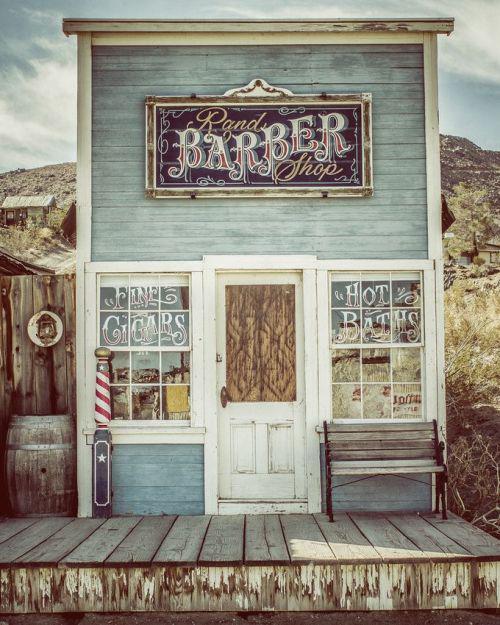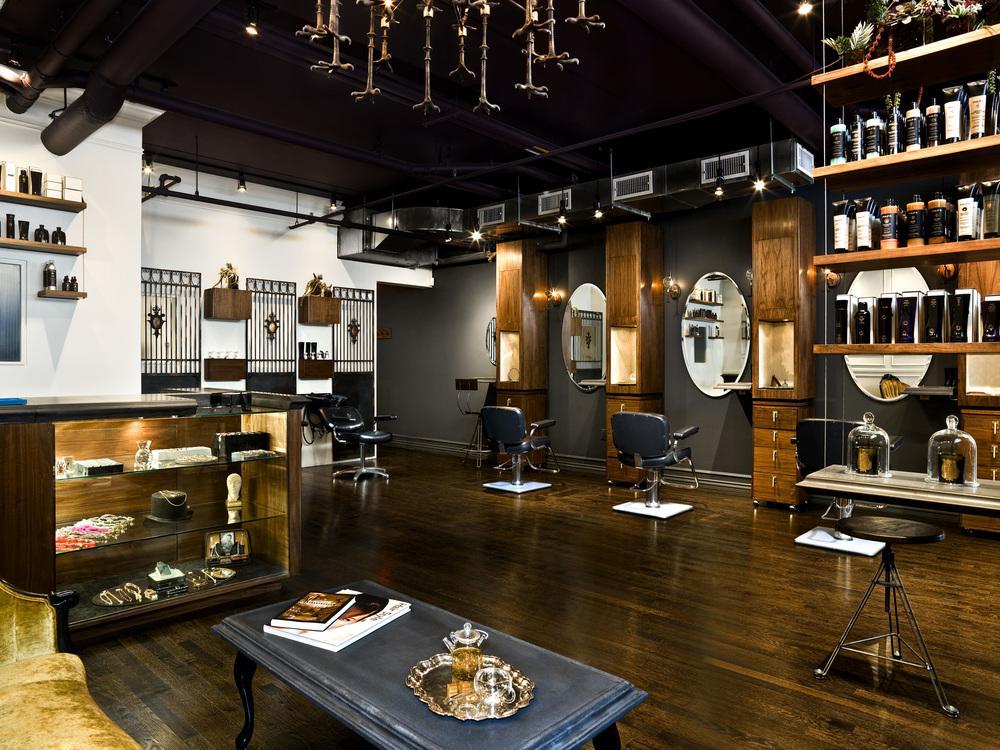The first image is the image on the left, the second image is the image on the right. For the images displayed, is the sentence "There is a barber pole in the image on the left." factually correct? Answer yes or no. Yes. 